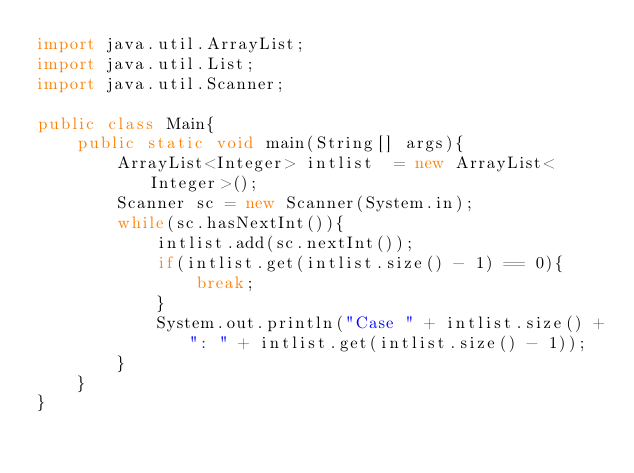<code> <loc_0><loc_0><loc_500><loc_500><_Java_>import java.util.ArrayList;
import java.util.List;
import java.util.Scanner;

public class Main{
    public static void main(String[] args){
        ArrayList<Integer> intlist  = new ArrayList<Integer>();
        Scanner sc = new Scanner(System.in);
        while(sc.hasNextInt()){
            intlist.add(sc.nextInt());
            if(intlist.get(intlist.size() - 1) == 0){
                break;
            }
            System.out.println("Case " + intlist.size() +": " + intlist.get(intlist.size() - 1));
        }
    }
}
</code> 